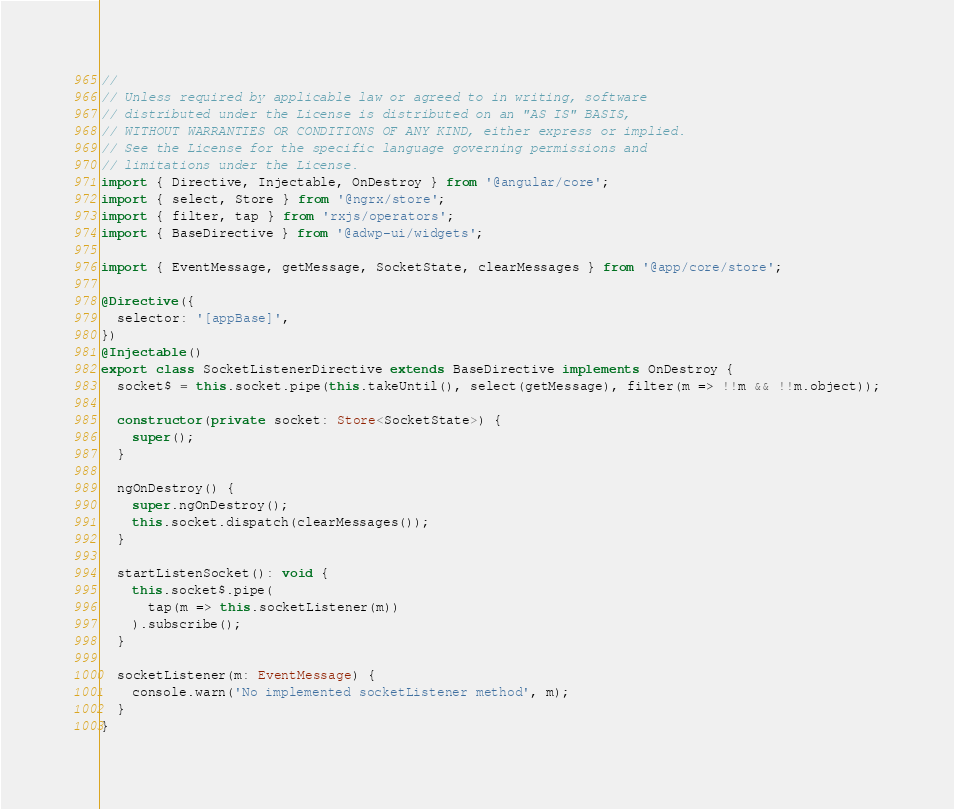<code> <loc_0><loc_0><loc_500><loc_500><_TypeScript_>//
// Unless required by applicable law or agreed to in writing, software
// distributed under the License is distributed on an "AS IS" BASIS,
// WITHOUT WARRANTIES OR CONDITIONS OF ANY KIND, either express or implied.
// See the License for the specific language governing permissions and
// limitations under the License.
import { Directive, Injectable, OnDestroy } from '@angular/core';
import { select, Store } from '@ngrx/store';
import { filter, tap } from 'rxjs/operators';
import { BaseDirective } from '@adwp-ui/widgets';

import { EventMessage, getMessage, SocketState, clearMessages } from '@app/core/store';

@Directive({
  selector: '[appBase]',
})
@Injectable()
export class SocketListenerDirective extends BaseDirective implements OnDestroy {
  socket$ = this.socket.pipe(this.takeUntil(), select(getMessage), filter(m => !!m && !!m.object));

  constructor(private socket: Store<SocketState>) {
    super();
  }

  ngOnDestroy() {
    super.ngOnDestroy();
    this.socket.dispatch(clearMessages());
  }

  startListenSocket(): void {
    this.socket$.pipe(
      tap(m => this.socketListener(m))
    ).subscribe();
  }

  socketListener(m: EventMessage) {
    console.warn('No implemented socketListener method', m);
  }
}
</code> 